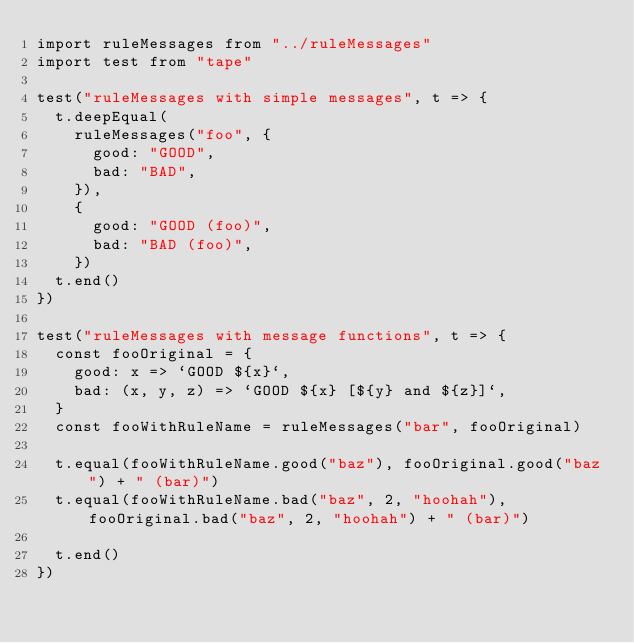Convert code to text. <code><loc_0><loc_0><loc_500><loc_500><_JavaScript_>import ruleMessages from "../ruleMessages"
import test from "tape"

test("ruleMessages with simple messages", t => {
  t.deepEqual(
    ruleMessages("foo", {
      good: "GOOD",
      bad: "BAD",
    }),
    {
      good: "GOOD (foo)",
      bad: "BAD (foo)",
    })
  t.end()
})

test("ruleMessages with message functions", t => {
  const fooOriginal = {
    good: x => `GOOD ${x}`,
    bad: (x, y, z) => `GOOD ${x} [${y} and ${z}]`,
  }
  const fooWithRuleName = ruleMessages("bar", fooOriginal)

  t.equal(fooWithRuleName.good("baz"), fooOriginal.good("baz") + " (bar)")
  t.equal(fooWithRuleName.bad("baz", 2, "hoohah"), fooOriginal.bad("baz", 2, "hoohah") + " (bar)")

  t.end()
})
</code> 